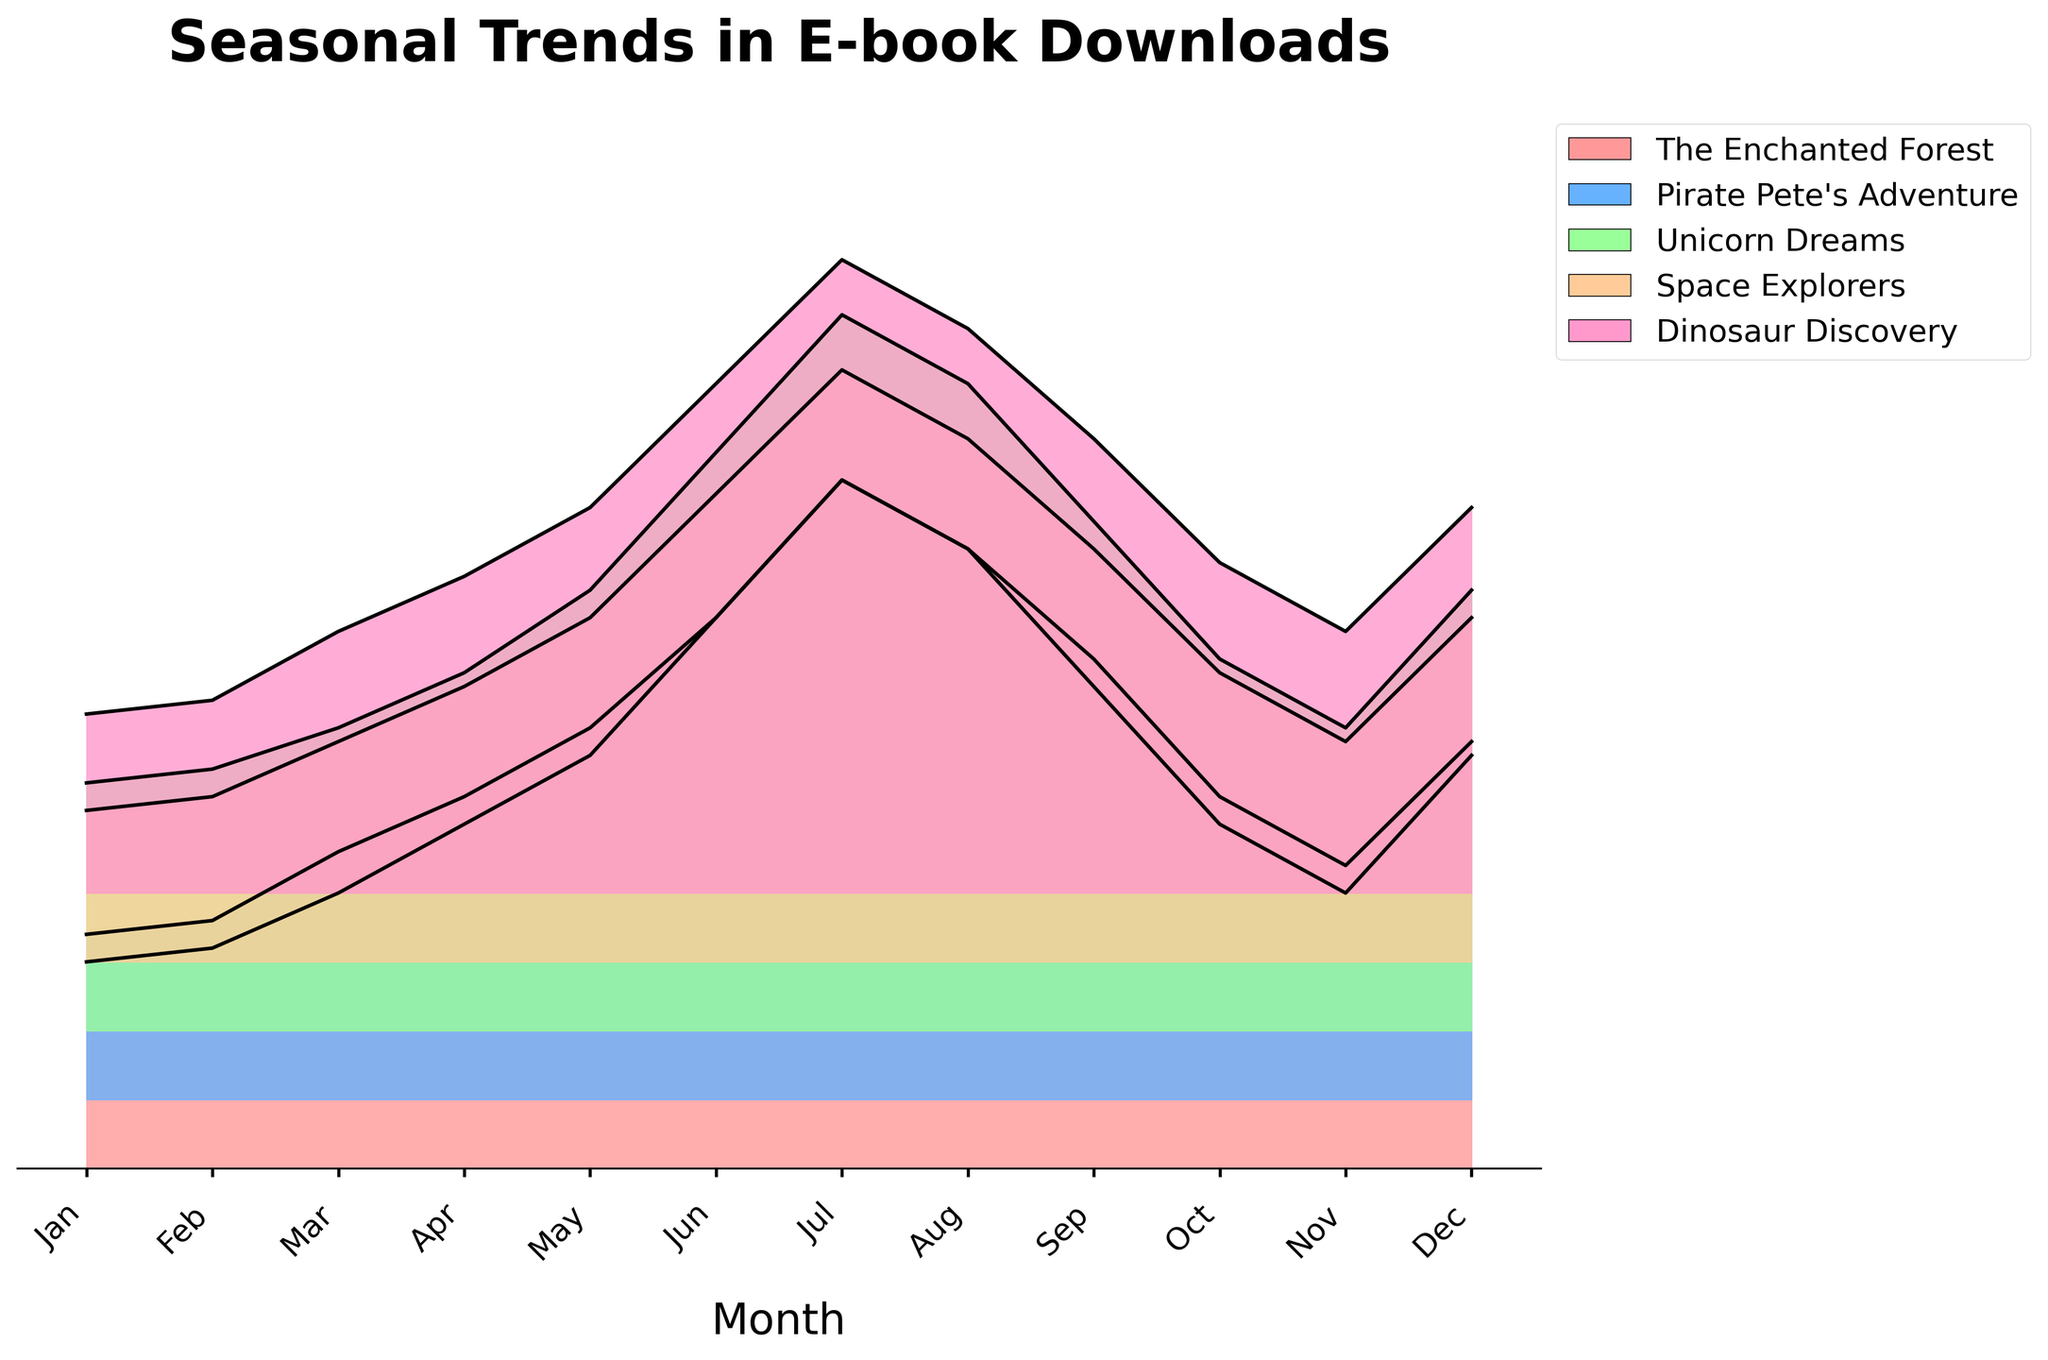What's the title of the plot? The title of the plot is usually located at the top of the figure. From the text, it is "Seasonal Trends in E-book Downloads".
Answer: Seasonal Trends in E-book Downloads How many books are being compared in the plot? The plot includes several segments, each representing a different book. Counting these segments can indicate the number of books compared.
Answer: 5 Which month shows the highest download for "The Enchanted Forest"? Look for the peak point for "The Enchanted Forest" in the plot, which is the highest point in its section. This occurs in July.
Answer: July In which months does "Dinosaur Discovery" download drop below 200? Check the "Dinosaur Discovery" line in the plot for points that fall below the 200 mark and note their corresponding months. These are January, February, October, and November.
Answer: January, February, October, November What is the general trend observed for "Space Explorers" throughout the year? Observe the "Space Explorers" section in the plot for any notable trends over the months. The download rate increases from January to July and then decreases until December.
Answer: Increase until July, then decrease Which book has the least variation in downloads across the months? Look across all the ridgelines and identify which one appears to have the least fluctuation in height. "Pirate Pete's Adventure" has the most consistent trend.
Answer: Pirate Pete's Adventure What is the combined total of downloads for "Unicorn Dreams" in March and April? Sum the values for "Unicorn Dreams" downloads in March (220) and April (260).
Answer: 480 Which month has the highest overall downloads if we sum up all books' downloads? Sum the download values for all books for each month and identify the month with the highest total. July has the highest cumulative total.
Answer: July Compare the downloads for "The Enchanted Forest" and "Space Explorers" in December. Which one had more downloads? Look at the points in December for both "The Enchanted Forest" (300) and "Space Explorers" (250) and compare them.
Answer: The Enchanted Forest Is there a month where the download numbers for all books are increasing? Examine the data trends for all books and identify if there is a month where every book shows an increase in downloads compared to the previous month, March to April shows increasing trends for all books.
Answer: March to April 